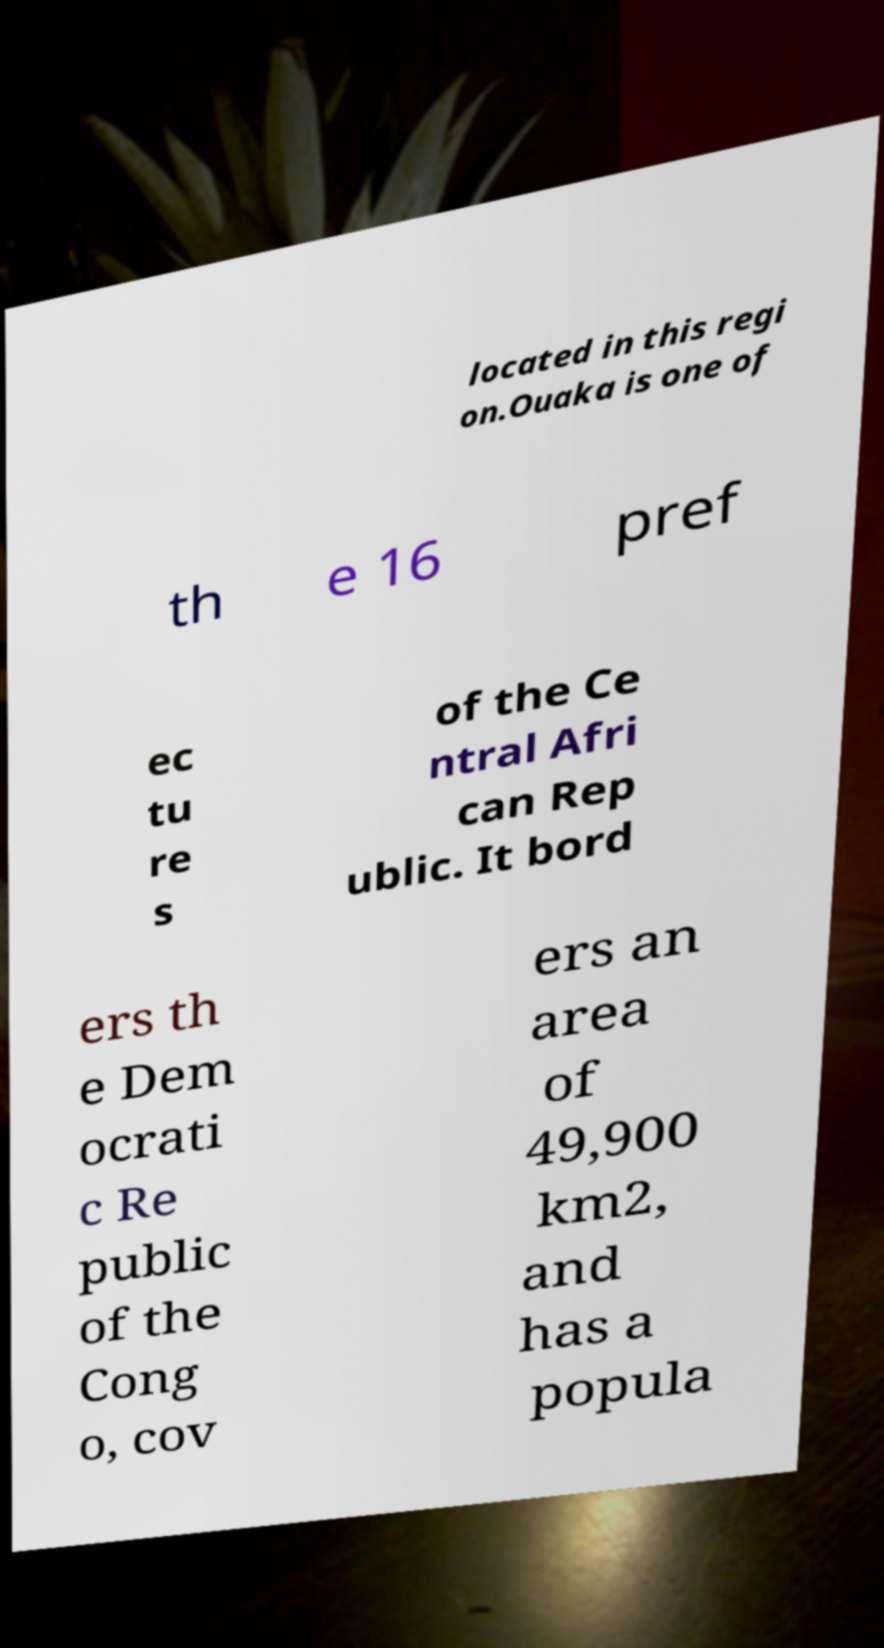For documentation purposes, I need the text within this image transcribed. Could you provide that? located in this regi on.Ouaka is one of th e 16 pref ec tu re s of the Ce ntral Afri can Rep ublic. It bord ers th e Dem ocrati c Re public of the Cong o, cov ers an area of 49,900 km2, and has a popula 